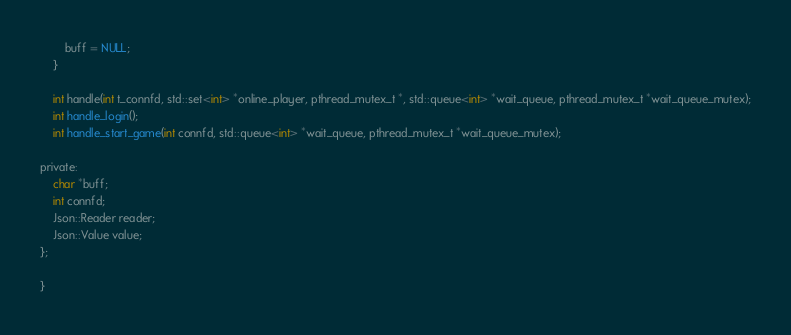<code> <loc_0><loc_0><loc_500><loc_500><_C_>		buff = NULL;
	}

	int handle(int t_connfd, std::set<int> *online_player, pthread_mutex_t *, std::queue<int> *wait_queue, pthread_mutex_t *wait_queue_mutex);
	int handle_login();
	int handle_start_game(int connfd, std::queue<int> *wait_queue, pthread_mutex_t *wait_queue_mutex);

private:
	char *buff;
	int connfd;
	Json::Reader reader;
	Json::Value value;
};

}
</code> 